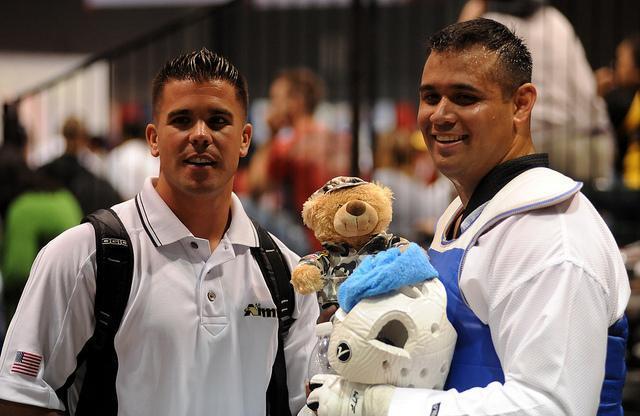How many teddy bears can you see?
Give a very brief answer. 1. How many people are visible?
Give a very brief answer. 4. 